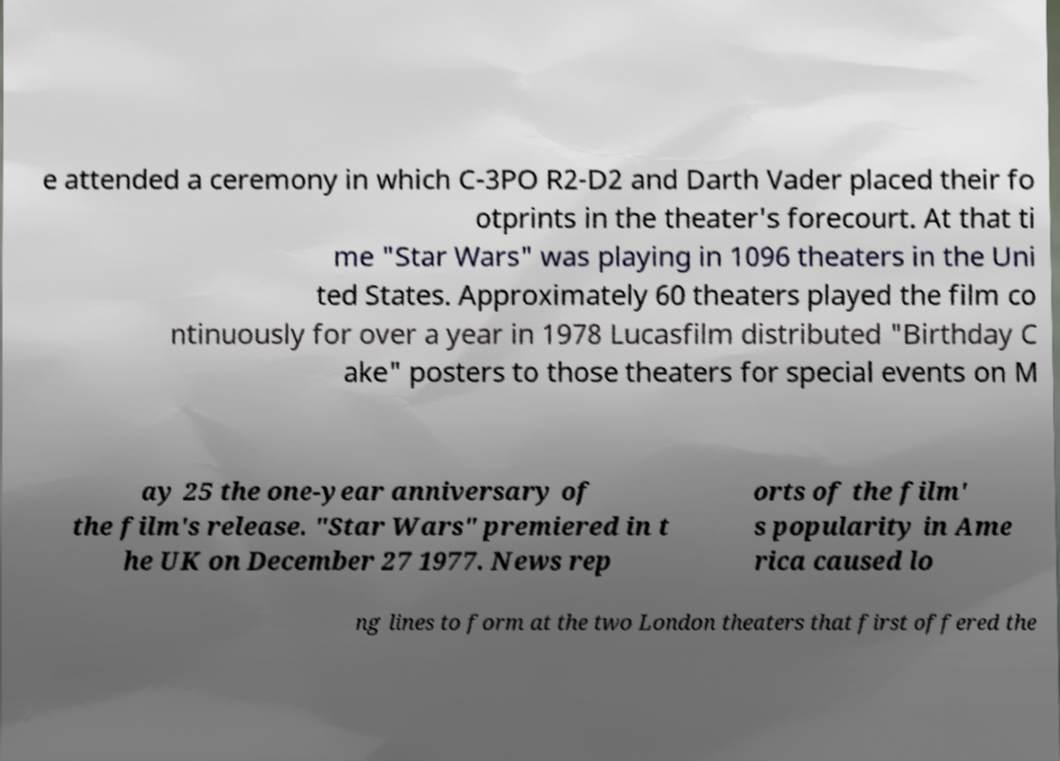For documentation purposes, I need the text within this image transcribed. Could you provide that? e attended a ceremony in which C-3PO R2-D2 and Darth Vader placed their fo otprints in the theater's forecourt. At that ti me "Star Wars" was playing in 1096 theaters in the Uni ted States. Approximately 60 theaters played the film co ntinuously for over a year in 1978 Lucasfilm distributed "Birthday C ake" posters to those theaters for special events on M ay 25 the one-year anniversary of the film's release. "Star Wars" premiered in t he UK on December 27 1977. News rep orts of the film' s popularity in Ame rica caused lo ng lines to form at the two London theaters that first offered the 